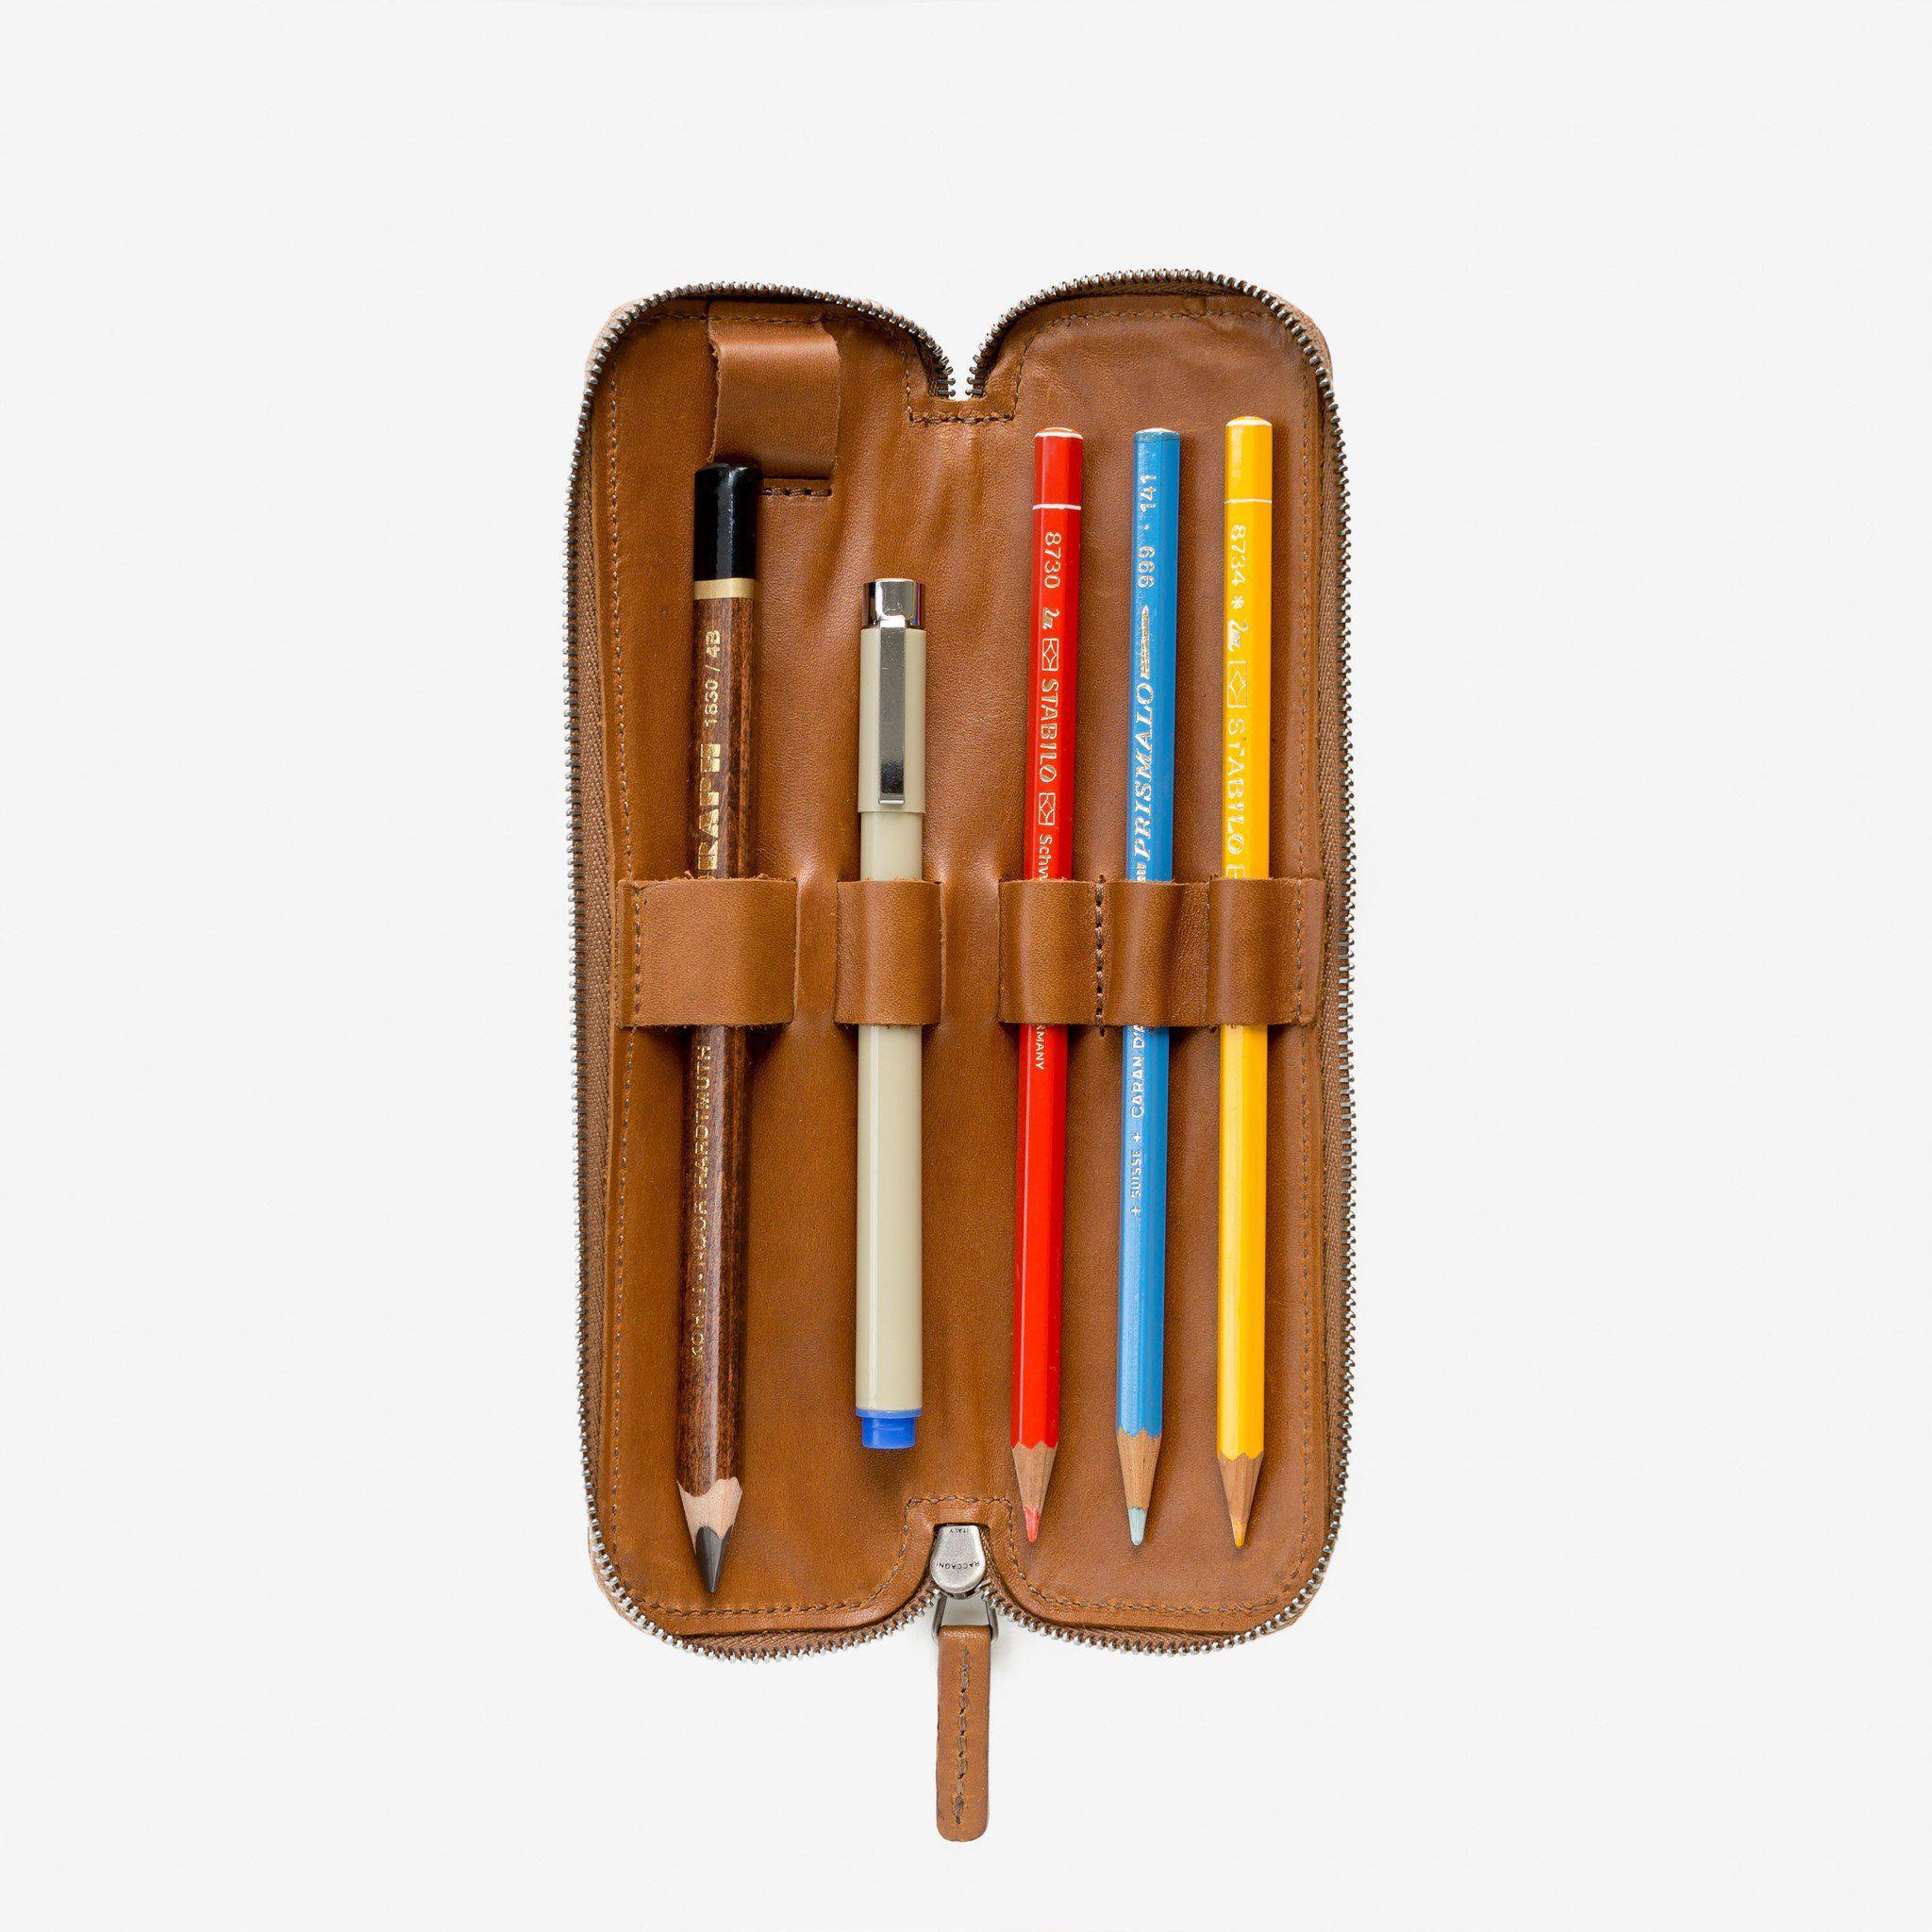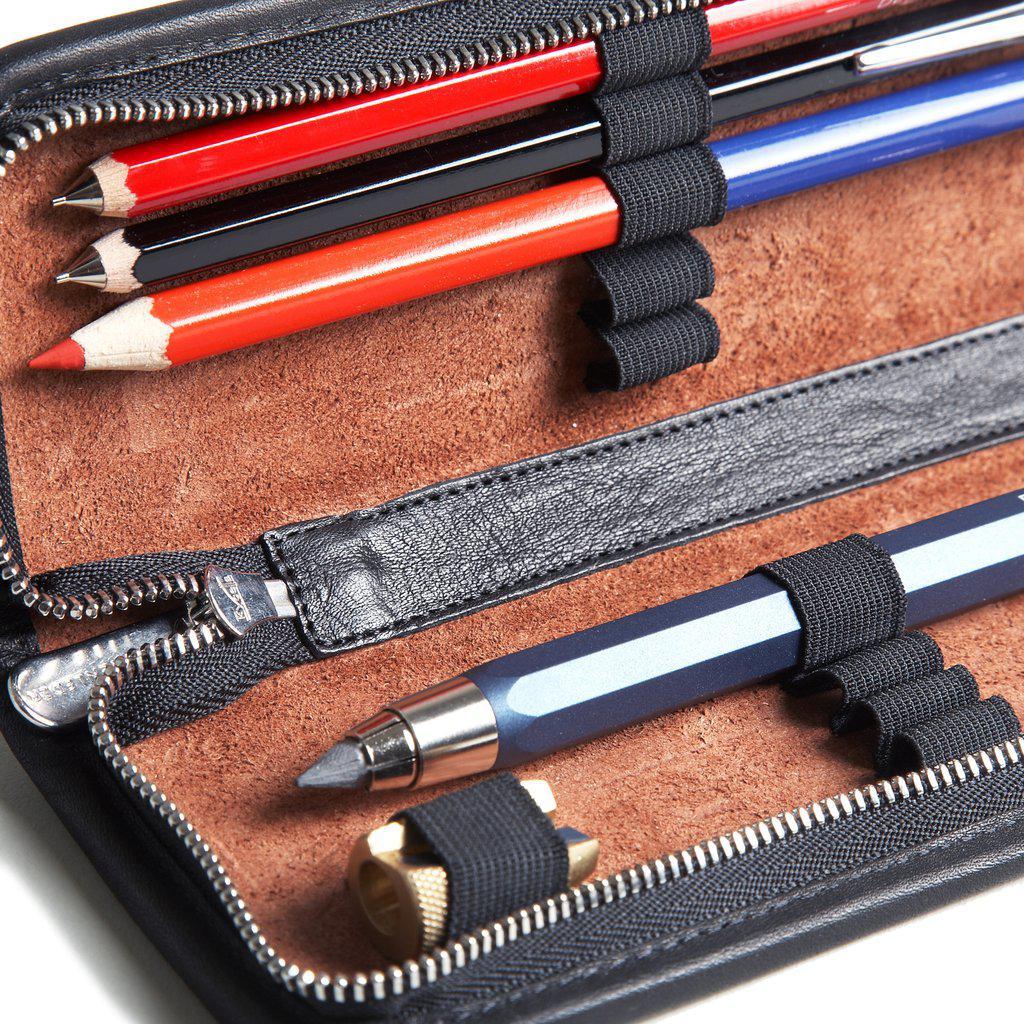The first image is the image on the left, the second image is the image on the right. Given the left and right images, does the statement "There is an image of a single closed case and an image showing both the closed and open case." hold true? Answer yes or no. No. The first image is the image on the left, the second image is the image on the right. Evaluate the accuracy of this statement regarding the images: "At least one of the images shows multiple colored pencils that are secured inside of a case.". Is it true? Answer yes or no. Yes. 